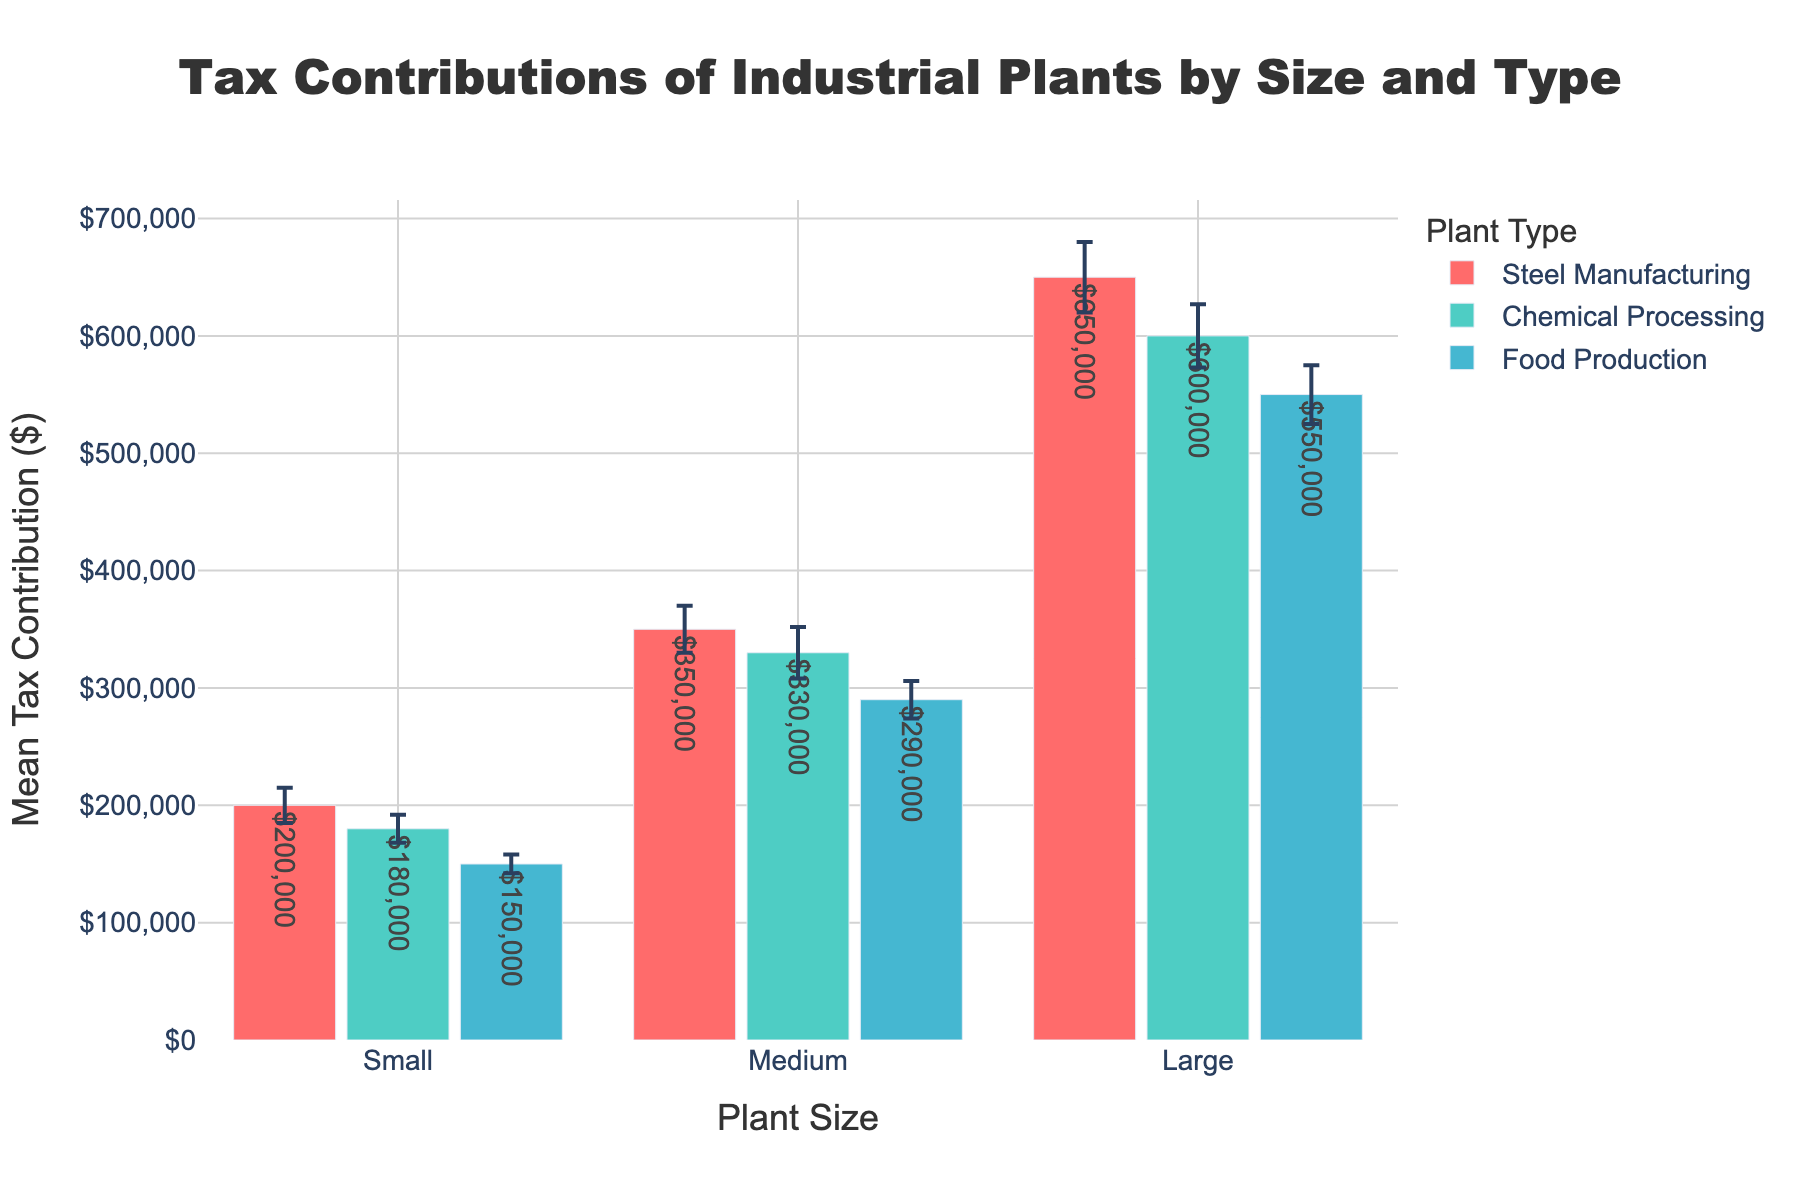What is the title of the chart? The title of the chart is located at the top and is clearly labeled. It reads, "Tax Contributions of Industrial Plants by Size and Type."
Answer: Tax Contributions of Industrial Plants by Size and Type Which plant size in Steel Manufacturing has the highest mean tax contribution? In the Steel Manufacturing category, the largest plant size has the highest mean tax contribution. This is indicated by the tallest bar, which is labeled with the largest value.
Answer: Large What are the color codes for the different plant types? The chart uses different colors to represent different plant types: Steel Manufacturing, Chemical Processing, and Food Production. These colors can be seen in the legend. Steel Manufacturing is red, Chemical Processing is teal, and Food Production is light blue.
Answer: Steel Manufacturing: red, Chemical Processing: teal, Food Production: light blue What is the mean tax contribution of a medium-sized plant in Chemical Processing? Locate the teal bars which represent Chemical Processing and find the bar labeled 'Medium'. The mean tax contribution shown next to the bar is $330,000.
Answer: $330,000 Which plant type has the smallest mean tax contribution and what is the value? To find the smallest mean tax contribution, look for the shortest bar across all plant types. The Food Production category for small plants has the smallest value, which is $150,000.
Answer: Food Production, Small, $150,000 What is the difference in mean tax contribution between small and large plants in Chemical Processing? To calculate the difference, find the mean tax contributions for small and large plants in the Chemical Processing category (teal bars): $180,000 for small and $600,000 for large. Then subtract the smaller value from the larger one: $600,000 - $180,000 = $420,000.
Answer: $420,000 Which plant size category shows the largest standard deviation in Steel Manufacturing? In the Steel Manufacturing category (red bars), compare the error bars for small, medium, and large plant sizes. The largest error bar, indicating the largest standard deviation, belongs to the large plant size.
Answer: Large How does the mean tax contribution of medium-sized Food Production plants compare to small-sized Steel Manufacturing plants? For medium-sized Food Production (light blue bars) the mean tax contribution is $290,000. For small-sized Steel Manufacturing (red bars), the mean tax contribution is $200,000. Therefore, the contribution for medium-sized Food Production plants is higher.
Answer: Medium-sized Food Production is higher What is the total mean tax contribution of all medium-sized plants across all categories? Sum up the mean tax contributions for medium-sized plants. For Steel Manufacturing: $350,000, Chemical Processing: $330,000, Food Production: $290,000. The total is $350,000 + $330,000 + $290,000 = $970,000.
Answer: $970,000 Which plant size in Food Production has the lowest error bar, indicating the smallest standard deviation? Check the error bars of the light blue bars representing Food Production. The smallest error bar is for the small plant size.
Answer: Small 